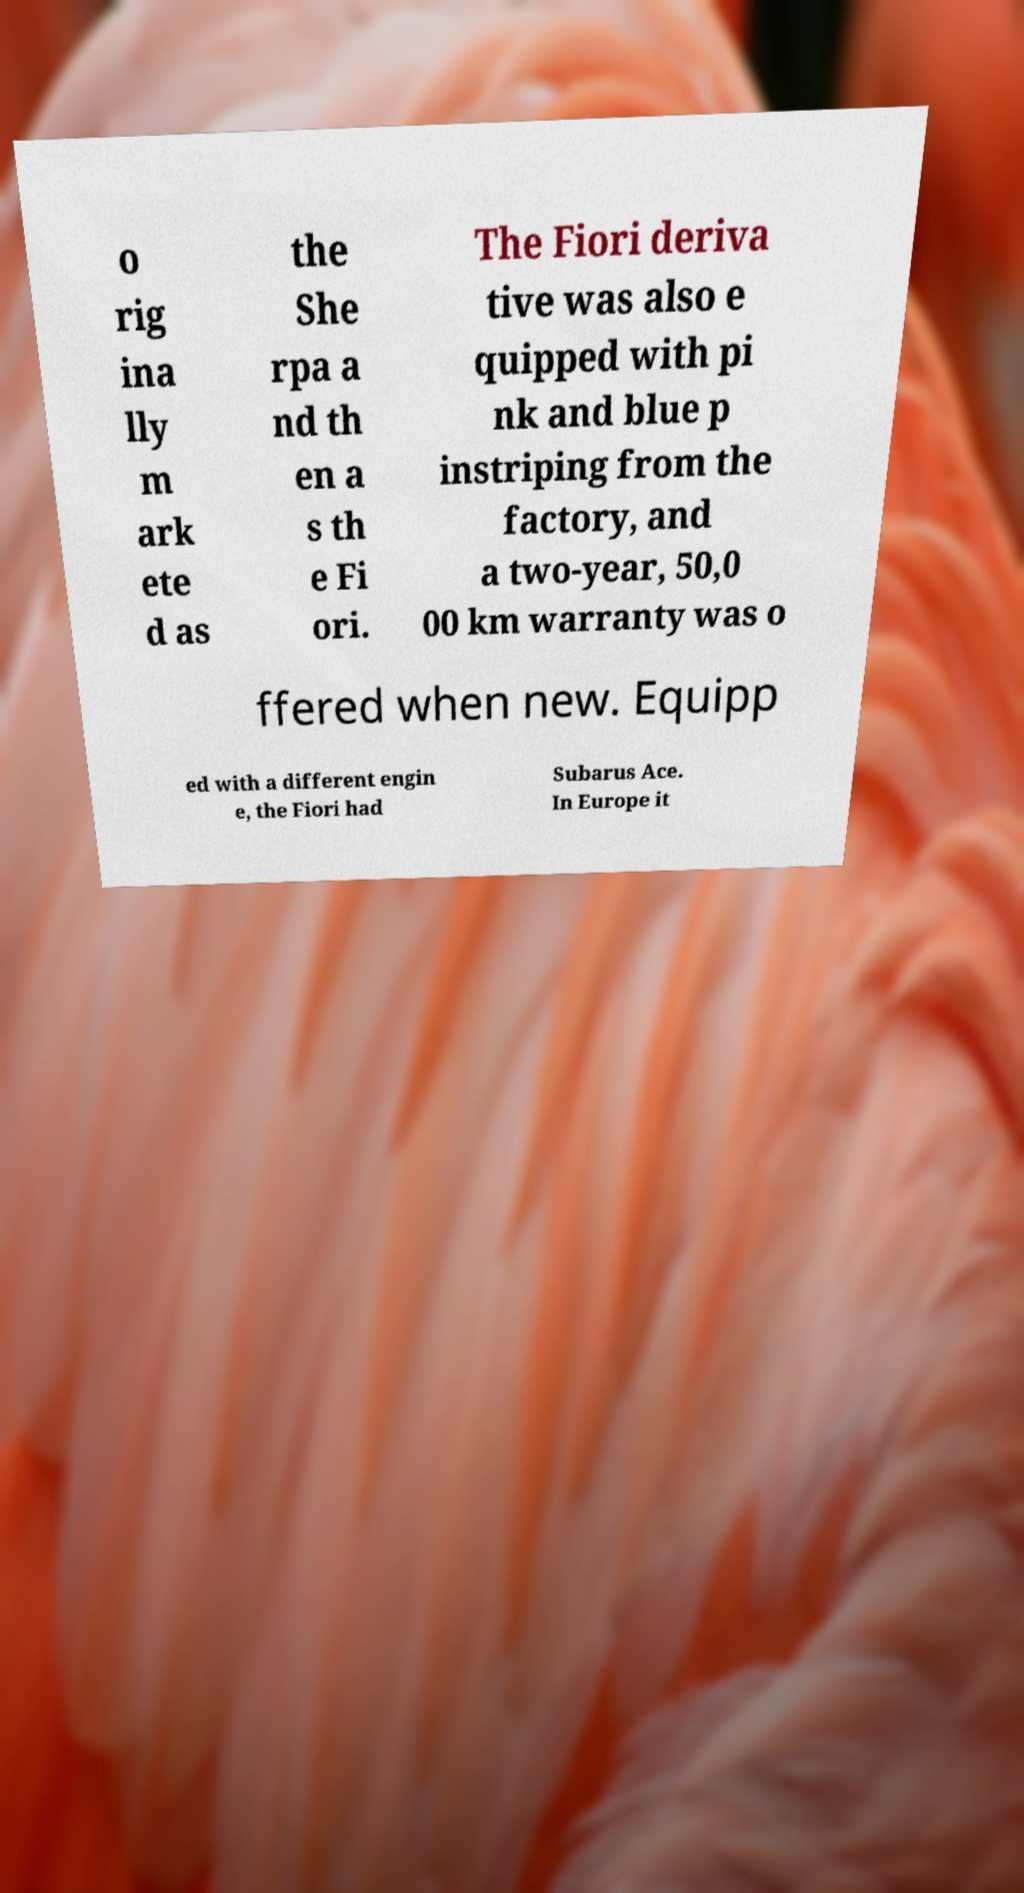Could you extract and type out the text from this image? o rig ina lly m ark ete d as the She rpa a nd th en a s th e Fi ori. The Fiori deriva tive was also e quipped with pi nk and blue p instriping from the factory, and a two-year, 50,0 00 km warranty was o ffered when new. Equipp ed with a different engin e, the Fiori had Subarus Ace. In Europe it 